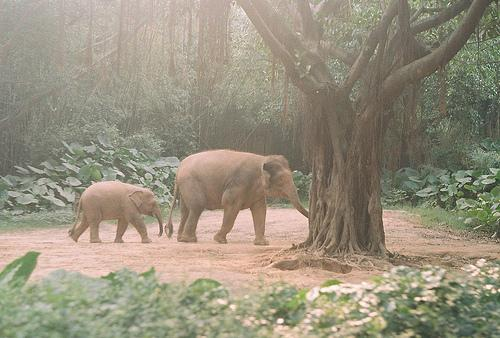Create a piece of engaging advertising copy utilizing the image. "Experience the magic of wildlife - Join our eco-safari adventure and witness the gentle giants of the forest in their natural habitat!" What condition is the ground in the image? The ground is brown, dry, and dusty. In the context of the image, what makes this scene special or noteworthy? The image captures a tender moment of a baby elephant walking behind a larger elephant in a lush forest setting, showcasing the beauty of nature and the bond between elephants. What is the most prominent animal species in the image, and what color are their bodies? The most prominent animal species is elephants, and their bodies are brown. For the visual entailment task, specify whether it's true or false that there is a baby elephant behind a larger elephant. True In the referential expression grounding task, find and describe a specific detail related to the baby elephant. The baby elephant has a small ear and a leg up in the air as it walks. In the multi-choice VQA task, choose the correct option: What is above the elephants? (a) blue sky (b) green leaves (c) brown ground (b) green leaves Identify the primary focus of the image and what colors can be seen. The main focus is a baby elephant and a larger elephant walking, with colors brown, green, and some white highlights on the leaves. Describe the key features of the background focusing on the flora. The background features a variety of green leaves on trees with thin trunks, many branches, and sunlight shining through. What type of advertisement could this image be suited for? An advertisement for a wildlife conservation initiative or an eco-tourism destination. 